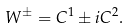Convert formula to latex. <formula><loc_0><loc_0><loc_500><loc_500>W ^ { \pm } = C ^ { 1 } \pm i C ^ { 2 } .</formula> 